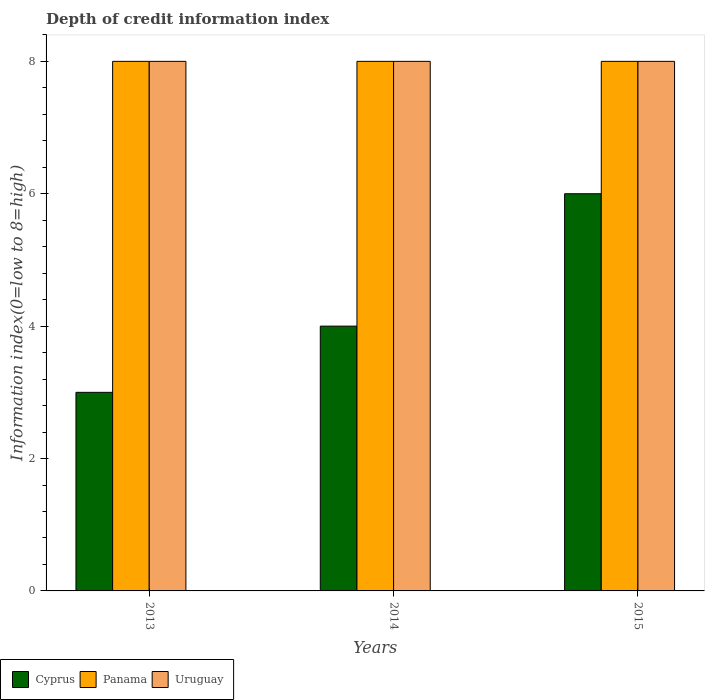How many different coloured bars are there?
Give a very brief answer. 3. What is the information index in Panama in 2015?
Keep it short and to the point. 8. Across all years, what is the minimum information index in Cyprus?
Keep it short and to the point. 3. In which year was the information index in Uruguay maximum?
Offer a very short reply. 2013. What is the total information index in Uruguay in the graph?
Offer a very short reply. 24. What is the difference between the information index in Panama in 2013 and that in 2015?
Provide a succinct answer. 0. What is the difference between the information index in Panama in 2015 and the information index in Cyprus in 2013?
Your response must be concise. 5. What is the average information index in Uruguay per year?
Ensure brevity in your answer.  8. In the year 2015, what is the difference between the information index in Uruguay and information index in Panama?
Your answer should be very brief. 0. Is the difference between the information index in Uruguay in 2013 and 2015 greater than the difference between the information index in Panama in 2013 and 2015?
Keep it short and to the point. No. What is the difference between the highest and the lowest information index in Cyprus?
Offer a terse response. 3. Is the sum of the information index in Uruguay in 2013 and 2014 greater than the maximum information index in Panama across all years?
Keep it short and to the point. Yes. What does the 3rd bar from the left in 2014 represents?
Ensure brevity in your answer.  Uruguay. What does the 1st bar from the right in 2013 represents?
Ensure brevity in your answer.  Uruguay. How many bars are there?
Your answer should be compact. 9. Are all the bars in the graph horizontal?
Give a very brief answer. No. How many years are there in the graph?
Your answer should be compact. 3. What is the difference between two consecutive major ticks on the Y-axis?
Offer a terse response. 2. Does the graph contain any zero values?
Your answer should be very brief. No. Where does the legend appear in the graph?
Offer a very short reply. Bottom left. How are the legend labels stacked?
Ensure brevity in your answer.  Horizontal. What is the title of the graph?
Provide a succinct answer. Depth of credit information index. Does "Bhutan" appear as one of the legend labels in the graph?
Keep it short and to the point. No. What is the label or title of the X-axis?
Give a very brief answer. Years. What is the label or title of the Y-axis?
Your answer should be compact. Information index(0=low to 8=high). What is the Information index(0=low to 8=high) of Panama in 2013?
Ensure brevity in your answer.  8. What is the Information index(0=low to 8=high) in Uruguay in 2013?
Your answer should be very brief. 8. What is the Information index(0=low to 8=high) in Cyprus in 2014?
Make the answer very short. 4. What is the Information index(0=low to 8=high) of Panama in 2014?
Provide a succinct answer. 8. What is the Information index(0=low to 8=high) in Uruguay in 2014?
Offer a terse response. 8. What is the Information index(0=low to 8=high) in Uruguay in 2015?
Offer a terse response. 8. Across all years, what is the maximum Information index(0=low to 8=high) of Uruguay?
Your answer should be compact. 8. Across all years, what is the minimum Information index(0=low to 8=high) in Panama?
Provide a short and direct response. 8. Across all years, what is the minimum Information index(0=low to 8=high) in Uruguay?
Provide a short and direct response. 8. What is the total Information index(0=low to 8=high) in Panama in the graph?
Your response must be concise. 24. What is the difference between the Information index(0=low to 8=high) of Cyprus in 2013 and that in 2015?
Your answer should be compact. -3. What is the difference between the Information index(0=low to 8=high) in Cyprus in 2014 and that in 2015?
Keep it short and to the point. -2. What is the difference between the Information index(0=low to 8=high) of Panama in 2014 and that in 2015?
Make the answer very short. 0. What is the difference between the Information index(0=low to 8=high) of Cyprus in 2013 and the Information index(0=low to 8=high) of Panama in 2014?
Offer a very short reply. -5. What is the difference between the Information index(0=low to 8=high) of Panama in 2013 and the Information index(0=low to 8=high) of Uruguay in 2014?
Provide a succinct answer. 0. What is the difference between the Information index(0=low to 8=high) in Panama in 2013 and the Information index(0=low to 8=high) in Uruguay in 2015?
Provide a short and direct response. 0. What is the difference between the Information index(0=low to 8=high) in Cyprus in 2014 and the Information index(0=low to 8=high) in Panama in 2015?
Make the answer very short. -4. What is the average Information index(0=low to 8=high) in Cyprus per year?
Offer a very short reply. 4.33. What is the average Information index(0=low to 8=high) of Uruguay per year?
Your response must be concise. 8. In the year 2014, what is the difference between the Information index(0=low to 8=high) of Cyprus and Information index(0=low to 8=high) of Panama?
Offer a terse response. -4. In the year 2014, what is the difference between the Information index(0=low to 8=high) in Panama and Information index(0=low to 8=high) in Uruguay?
Your answer should be compact. 0. In the year 2015, what is the difference between the Information index(0=low to 8=high) in Panama and Information index(0=low to 8=high) in Uruguay?
Your answer should be compact. 0. What is the ratio of the Information index(0=low to 8=high) in Cyprus in 2013 to that in 2014?
Make the answer very short. 0.75. What is the ratio of the Information index(0=low to 8=high) of Panama in 2013 to that in 2014?
Your answer should be very brief. 1. What is the ratio of the Information index(0=low to 8=high) of Cyprus in 2013 to that in 2015?
Provide a succinct answer. 0.5. What is the ratio of the Information index(0=low to 8=high) in Panama in 2013 to that in 2015?
Provide a succinct answer. 1. What is the ratio of the Information index(0=low to 8=high) in Cyprus in 2014 to that in 2015?
Offer a very short reply. 0.67. What is the ratio of the Information index(0=low to 8=high) in Panama in 2014 to that in 2015?
Your response must be concise. 1. What is the difference between the highest and the second highest Information index(0=low to 8=high) in Cyprus?
Your answer should be compact. 2. What is the difference between the highest and the lowest Information index(0=low to 8=high) in Cyprus?
Provide a short and direct response. 3. What is the difference between the highest and the lowest Information index(0=low to 8=high) in Panama?
Your answer should be compact. 0. What is the difference between the highest and the lowest Information index(0=low to 8=high) in Uruguay?
Keep it short and to the point. 0. 